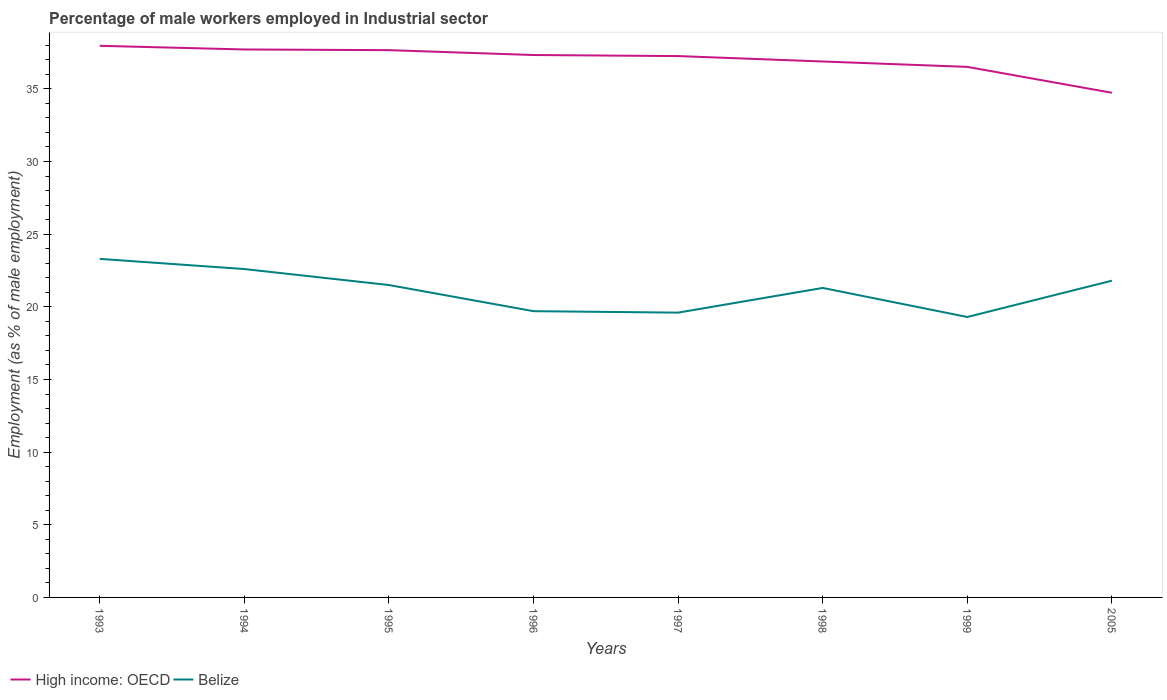Across all years, what is the maximum percentage of male workers employed in Industrial sector in High income: OECD?
Your answer should be compact. 34.73. What is the total percentage of male workers employed in Industrial sector in High income: OECD in the graph?
Offer a very short reply. 1.2. What is the difference between the highest and the second highest percentage of male workers employed in Industrial sector in Belize?
Keep it short and to the point. 4. What is the difference between the highest and the lowest percentage of male workers employed in Industrial sector in Belize?
Your response must be concise. 5. Are the values on the major ticks of Y-axis written in scientific E-notation?
Your answer should be very brief. No. Does the graph contain any zero values?
Make the answer very short. No. Where does the legend appear in the graph?
Your response must be concise. Bottom left. What is the title of the graph?
Give a very brief answer. Percentage of male workers employed in Industrial sector. Does "High income: nonOECD" appear as one of the legend labels in the graph?
Keep it short and to the point. No. What is the label or title of the Y-axis?
Your answer should be compact. Employment (as % of male employment). What is the Employment (as % of male employment) in High income: OECD in 1993?
Your response must be concise. 37.96. What is the Employment (as % of male employment) in Belize in 1993?
Offer a very short reply. 23.3. What is the Employment (as % of male employment) in High income: OECD in 1994?
Your answer should be very brief. 37.71. What is the Employment (as % of male employment) of Belize in 1994?
Keep it short and to the point. 22.6. What is the Employment (as % of male employment) of High income: OECD in 1995?
Your response must be concise. 37.66. What is the Employment (as % of male employment) of High income: OECD in 1996?
Your answer should be very brief. 37.33. What is the Employment (as % of male employment) of Belize in 1996?
Your response must be concise. 19.7. What is the Employment (as % of male employment) in High income: OECD in 1997?
Your answer should be very brief. 37.26. What is the Employment (as % of male employment) in Belize in 1997?
Give a very brief answer. 19.6. What is the Employment (as % of male employment) in High income: OECD in 1998?
Your answer should be very brief. 36.88. What is the Employment (as % of male employment) of Belize in 1998?
Offer a very short reply. 21.3. What is the Employment (as % of male employment) of High income: OECD in 1999?
Provide a succinct answer. 36.51. What is the Employment (as % of male employment) of Belize in 1999?
Keep it short and to the point. 19.3. What is the Employment (as % of male employment) in High income: OECD in 2005?
Keep it short and to the point. 34.73. What is the Employment (as % of male employment) in Belize in 2005?
Your answer should be compact. 21.8. Across all years, what is the maximum Employment (as % of male employment) of High income: OECD?
Provide a short and direct response. 37.96. Across all years, what is the maximum Employment (as % of male employment) of Belize?
Offer a terse response. 23.3. Across all years, what is the minimum Employment (as % of male employment) of High income: OECD?
Your response must be concise. 34.73. Across all years, what is the minimum Employment (as % of male employment) in Belize?
Your answer should be compact. 19.3. What is the total Employment (as % of male employment) in High income: OECD in the graph?
Your response must be concise. 296.05. What is the total Employment (as % of male employment) of Belize in the graph?
Offer a terse response. 169.1. What is the difference between the Employment (as % of male employment) in High income: OECD in 1993 and that in 1994?
Give a very brief answer. 0.25. What is the difference between the Employment (as % of male employment) of High income: OECD in 1993 and that in 1995?
Keep it short and to the point. 0.3. What is the difference between the Employment (as % of male employment) of High income: OECD in 1993 and that in 1996?
Provide a short and direct response. 0.63. What is the difference between the Employment (as % of male employment) in Belize in 1993 and that in 1996?
Offer a terse response. 3.6. What is the difference between the Employment (as % of male employment) of High income: OECD in 1993 and that in 1997?
Make the answer very short. 0.71. What is the difference between the Employment (as % of male employment) of High income: OECD in 1993 and that in 1998?
Offer a very short reply. 1.08. What is the difference between the Employment (as % of male employment) of High income: OECD in 1993 and that in 1999?
Provide a short and direct response. 1.45. What is the difference between the Employment (as % of male employment) in Belize in 1993 and that in 1999?
Keep it short and to the point. 4. What is the difference between the Employment (as % of male employment) of High income: OECD in 1993 and that in 2005?
Your answer should be very brief. 3.23. What is the difference between the Employment (as % of male employment) of High income: OECD in 1994 and that in 1995?
Give a very brief answer. 0.05. What is the difference between the Employment (as % of male employment) of High income: OECD in 1994 and that in 1996?
Keep it short and to the point. 0.38. What is the difference between the Employment (as % of male employment) of High income: OECD in 1994 and that in 1997?
Provide a succinct answer. 0.46. What is the difference between the Employment (as % of male employment) of High income: OECD in 1994 and that in 1998?
Keep it short and to the point. 0.83. What is the difference between the Employment (as % of male employment) in Belize in 1994 and that in 1998?
Give a very brief answer. 1.3. What is the difference between the Employment (as % of male employment) of High income: OECD in 1994 and that in 1999?
Ensure brevity in your answer.  1.2. What is the difference between the Employment (as % of male employment) in High income: OECD in 1994 and that in 2005?
Give a very brief answer. 2.98. What is the difference between the Employment (as % of male employment) of Belize in 1994 and that in 2005?
Your answer should be very brief. 0.8. What is the difference between the Employment (as % of male employment) in High income: OECD in 1995 and that in 1996?
Offer a terse response. 0.33. What is the difference between the Employment (as % of male employment) of Belize in 1995 and that in 1996?
Give a very brief answer. 1.8. What is the difference between the Employment (as % of male employment) in High income: OECD in 1995 and that in 1997?
Your answer should be very brief. 0.41. What is the difference between the Employment (as % of male employment) of Belize in 1995 and that in 1997?
Keep it short and to the point. 1.9. What is the difference between the Employment (as % of male employment) of High income: OECD in 1995 and that in 1998?
Your answer should be compact. 0.78. What is the difference between the Employment (as % of male employment) of High income: OECD in 1995 and that in 1999?
Offer a very short reply. 1.15. What is the difference between the Employment (as % of male employment) in Belize in 1995 and that in 1999?
Ensure brevity in your answer.  2.2. What is the difference between the Employment (as % of male employment) in High income: OECD in 1995 and that in 2005?
Give a very brief answer. 2.93. What is the difference between the Employment (as % of male employment) in High income: OECD in 1996 and that in 1997?
Ensure brevity in your answer.  0.07. What is the difference between the Employment (as % of male employment) in Belize in 1996 and that in 1997?
Give a very brief answer. 0.1. What is the difference between the Employment (as % of male employment) of High income: OECD in 1996 and that in 1998?
Provide a short and direct response. 0.45. What is the difference between the Employment (as % of male employment) of Belize in 1996 and that in 1998?
Provide a succinct answer. -1.6. What is the difference between the Employment (as % of male employment) of High income: OECD in 1996 and that in 1999?
Offer a terse response. 0.82. What is the difference between the Employment (as % of male employment) of Belize in 1996 and that in 1999?
Make the answer very short. 0.4. What is the difference between the Employment (as % of male employment) in High income: OECD in 1996 and that in 2005?
Offer a very short reply. 2.6. What is the difference between the Employment (as % of male employment) in Belize in 1996 and that in 2005?
Provide a short and direct response. -2.1. What is the difference between the Employment (as % of male employment) of High income: OECD in 1997 and that in 1998?
Ensure brevity in your answer.  0.37. What is the difference between the Employment (as % of male employment) of Belize in 1997 and that in 1998?
Your answer should be very brief. -1.7. What is the difference between the Employment (as % of male employment) of High income: OECD in 1997 and that in 1999?
Give a very brief answer. 0.74. What is the difference between the Employment (as % of male employment) of High income: OECD in 1997 and that in 2005?
Ensure brevity in your answer.  2.52. What is the difference between the Employment (as % of male employment) in High income: OECD in 1998 and that in 1999?
Make the answer very short. 0.37. What is the difference between the Employment (as % of male employment) of Belize in 1998 and that in 1999?
Keep it short and to the point. 2. What is the difference between the Employment (as % of male employment) in High income: OECD in 1998 and that in 2005?
Your answer should be compact. 2.15. What is the difference between the Employment (as % of male employment) of High income: OECD in 1999 and that in 2005?
Provide a short and direct response. 1.78. What is the difference between the Employment (as % of male employment) in High income: OECD in 1993 and the Employment (as % of male employment) in Belize in 1994?
Provide a short and direct response. 15.36. What is the difference between the Employment (as % of male employment) of High income: OECD in 1993 and the Employment (as % of male employment) of Belize in 1995?
Provide a succinct answer. 16.46. What is the difference between the Employment (as % of male employment) in High income: OECD in 1993 and the Employment (as % of male employment) in Belize in 1996?
Provide a succinct answer. 18.26. What is the difference between the Employment (as % of male employment) in High income: OECD in 1993 and the Employment (as % of male employment) in Belize in 1997?
Your response must be concise. 18.36. What is the difference between the Employment (as % of male employment) of High income: OECD in 1993 and the Employment (as % of male employment) of Belize in 1998?
Provide a short and direct response. 16.66. What is the difference between the Employment (as % of male employment) in High income: OECD in 1993 and the Employment (as % of male employment) in Belize in 1999?
Keep it short and to the point. 18.66. What is the difference between the Employment (as % of male employment) in High income: OECD in 1993 and the Employment (as % of male employment) in Belize in 2005?
Your response must be concise. 16.16. What is the difference between the Employment (as % of male employment) of High income: OECD in 1994 and the Employment (as % of male employment) of Belize in 1995?
Ensure brevity in your answer.  16.21. What is the difference between the Employment (as % of male employment) in High income: OECD in 1994 and the Employment (as % of male employment) in Belize in 1996?
Your answer should be compact. 18.01. What is the difference between the Employment (as % of male employment) in High income: OECD in 1994 and the Employment (as % of male employment) in Belize in 1997?
Make the answer very short. 18.11. What is the difference between the Employment (as % of male employment) of High income: OECD in 1994 and the Employment (as % of male employment) of Belize in 1998?
Your response must be concise. 16.41. What is the difference between the Employment (as % of male employment) of High income: OECD in 1994 and the Employment (as % of male employment) of Belize in 1999?
Offer a very short reply. 18.41. What is the difference between the Employment (as % of male employment) of High income: OECD in 1994 and the Employment (as % of male employment) of Belize in 2005?
Your response must be concise. 15.91. What is the difference between the Employment (as % of male employment) in High income: OECD in 1995 and the Employment (as % of male employment) in Belize in 1996?
Your answer should be compact. 17.96. What is the difference between the Employment (as % of male employment) of High income: OECD in 1995 and the Employment (as % of male employment) of Belize in 1997?
Provide a succinct answer. 18.06. What is the difference between the Employment (as % of male employment) in High income: OECD in 1995 and the Employment (as % of male employment) in Belize in 1998?
Keep it short and to the point. 16.36. What is the difference between the Employment (as % of male employment) of High income: OECD in 1995 and the Employment (as % of male employment) of Belize in 1999?
Your answer should be compact. 18.36. What is the difference between the Employment (as % of male employment) of High income: OECD in 1995 and the Employment (as % of male employment) of Belize in 2005?
Give a very brief answer. 15.86. What is the difference between the Employment (as % of male employment) in High income: OECD in 1996 and the Employment (as % of male employment) in Belize in 1997?
Offer a very short reply. 17.73. What is the difference between the Employment (as % of male employment) of High income: OECD in 1996 and the Employment (as % of male employment) of Belize in 1998?
Offer a terse response. 16.03. What is the difference between the Employment (as % of male employment) of High income: OECD in 1996 and the Employment (as % of male employment) of Belize in 1999?
Make the answer very short. 18.03. What is the difference between the Employment (as % of male employment) in High income: OECD in 1996 and the Employment (as % of male employment) in Belize in 2005?
Make the answer very short. 15.53. What is the difference between the Employment (as % of male employment) in High income: OECD in 1997 and the Employment (as % of male employment) in Belize in 1998?
Ensure brevity in your answer.  15.96. What is the difference between the Employment (as % of male employment) of High income: OECD in 1997 and the Employment (as % of male employment) of Belize in 1999?
Give a very brief answer. 17.96. What is the difference between the Employment (as % of male employment) of High income: OECD in 1997 and the Employment (as % of male employment) of Belize in 2005?
Your answer should be very brief. 15.46. What is the difference between the Employment (as % of male employment) of High income: OECD in 1998 and the Employment (as % of male employment) of Belize in 1999?
Make the answer very short. 17.58. What is the difference between the Employment (as % of male employment) in High income: OECD in 1998 and the Employment (as % of male employment) in Belize in 2005?
Provide a short and direct response. 15.08. What is the difference between the Employment (as % of male employment) in High income: OECD in 1999 and the Employment (as % of male employment) in Belize in 2005?
Ensure brevity in your answer.  14.71. What is the average Employment (as % of male employment) in High income: OECD per year?
Make the answer very short. 37.01. What is the average Employment (as % of male employment) in Belize per year?
Keep it short and to the point. 21.14. In the year 1993, what is the difference between the Employment (as % of male employment) in High income: OECD and Employment (as % of male employment) in Belize?
Provide a short and direct response. 14.66. In the year 1994, what is the difference between the Employment (as % of male employment) of High income: OECD and Employment (as % of male employment) of Belize?
Your answer should be very brief. 15.11. In the year 1995, what is the difference between the Employment (as % of male employment) in High income: OECD and Employment (as % of male employment) in Belize?
Your answer should be compact. 16.16. In the year 1996, what is the difference between the Employment (as % of male employment) in High income: OECD and Employment (as % of male employment) in Belize?
Your answer should be compact. 17.63. In the year 1997, what is the difference between the Employment (as % of male employment) of High income: OECD and Employment (as % of male employment) of Belize?
Keep it short and to the point. 17.66. In the year 1998, what is the difference between the Employment (as % of male employment) of High income: OECD and Employment (as % of male employment) of Belize?
Give a very brief answer. 15.58. In the year 1999, what is the difference between the Employment (as % of male employment) of High income: OECD and Employment (as % of male employment) of Belize?
Offer a terse response. 17.21. In the year 2005, what is the difference between the Employment (as % of male employment) of High income: OECD and Employment (as % of male employment) of Belize?
Your response must be concise. 12.93. What is the ratio of the Employment (as % of male employment) of Belize in 1993 to that in 1994?
Give a very brief answer. 1.03. What is the ratio of the Employment (as % of male employment) of High income: OECD in 1993 to that in 1995?
Make the answer very short. 1.01. What is the ratio of the Employment (as % of male employment) of Belize in 1993 to that in 1995?
Your answer should be compact. 1.08. What is the ratio of the Employment (as % of male employment) of High income: OECD in 1993 to that in 1996?
Your answer should be very brief. 1.02. What is the ratio of the Employment (as % of male employment) of Belize in 1993 to that in 1996?
Ensure brevity in your answer.  1.18. What is the ratio of the Employment (as % of male employment) in Belize in 1993 to that in 1997?
Provide a short and direct response. 1.19. What is the ratio of the Employment (as % of male employment) of High income: OECD in 1993 to that in 1998?
Ensure brevity in your answer.  1.03. What is the ratio of the Employment (as % of male employment) in Belize in 1993 to that in 1998?
Ensure brevity in your answer.  1.09. What is the ratio of the Employment (as % of male employment) in High income: OECD in 1993 to that in 1999?
Your answer should be very brief. 1.04. What is the ratio of the Employment (as % of male employment) of Belize in 1993 to that in 1999?
Offer a terse response. 1.21. What is the ratio of the Employment (as % of male employment) in High income: OECD in 1993 to that in 2005?
Ensure brevity in your answer.  1.09. What is the ratio of the Employment (as % of male employment) in Belize in 1993 to that in 2005?
Offer a terse response. 1.07. What is the ratio of the Employment (as % of male employment) in Belize in 1994 to that in 1995?
Offer a very short reply. 1.05. What is the ratio of the Employment (as % of male employment) of High income: OECD in 1994 to that in 1996?
Your answer should be compact. 1.01. What is the ratio of the Employment (as % of male employment) of Belize in 1994 to that in 1996?
Offer a very short reply. 1.15. What is the ratio of the Employment (as % of male employment) of High income: OECD in 1994 to that in 1997?
Ensure brevity in your answer.  1.01. What is the ratio of the Employment (as % of male employment) of Belize in 1994 to that in 1997?
Your answer should be very brief. 1.15. What is the ratio of the Employment (as % of male employment) of High income: OECD in 1994 to that in 1998?
Make the answer very short. 1.02. What is the ratio of the Employment (as % of male employment) in Belize in 1994 to that in 1998?
Offer a terse response. 1.06. What is the ratio of the Employment (as % of male employment) in High income: OECD in 1994 to that in 1999?
Your answer should be compact. 1.03. What is the ratio of the Employment (as % of male employment) in Belize in 1994 to that in 1999?
Your answer should be compact. 1.17. What is the ratio of the Employment (as % of male employment) in High income: OECD in 1994 to that in 2005?
Give a very brief answer. 1.09. What is the ratio of the Employment (as % of male employment) of Belize in 1994 to that in 2005?
Make the answer very short. 1.04. What is the ratio of the Employment (as % of male employment) of Belize in 1995 to that in 1996?
Your response must be concise. 1.09. What is the ratio of the Employment (as % of male employment) of High income: OECD in 1995 to that in 1997?
Ensure brevity in your answer.  1.01. What is the ratio of the Employment (as % of male employment) in Belize in 1995 to that in 1997?
Make the answer very short. 1.1. What is the ratio of the Employment (as % of male employment) in High income: OECD in 1995 to that in 1998?
Your answer should be compact. 1.02. What is the ratio of the Employment (as % of male employment) in Belize in 1995 to that in 1998?
Your answer should be very brief. 1.01. What is the ratio of the Employment (as % of male employment) of High income: OECD in 1995 to that in 1999?
Your answer should be compact. 1.03. What is the ratio of the Employment (as % of male employment) of Belize in 1995 to that in 1999?
Offer a terse response. 1.11. What is the ratio of the Employment (as % of male employment) in High income: OECD in 1995 to that in 2005?
Your answer should be very brief. 1.08. What is the ratio of the Employment (as % of male employment) of Belize in 1995 to that in 2005?
Keep it short and to the point. 0.99. What is the ratio of the Employment (as % of male employment) of High income: OECD in 1996 to that in 1997?
Provide a succinct answer. 1. What is the ratio of the Employment (as % of male employment) in High income: OECD in 1996 to that in 1998?
Your answer should be compact. 1.01. What is the ratio of the Employment (as % of male employment) in Belize in 1996 to that in 1998?
Give a very brief answer. 0.92. What is the ratio of the Employment (as % of male employment) in High income: OECD in 1996 to that in 1999?
Provide a succinct answer. 1.02. What is the ratio of the Employment (as % of male employment) of Belize in 1996 to that in 1999?
Give a very brief answer. 1.02. What is the ratio of the Employment (as % of male employment) in High income: OECD in 1996 to that in 2005?
Offer a terse response. 1.07. What is the ratio of the Employment (as % of male employment) in Belize in 1996 to that in 2005?
Offer a very short reply. 0.9. What is the ratio of the Employment (as % of male employment) in High income: OECD in 1997 to that in 1998?
Provide a succinct answer. 1.01. What is the ratio of the Employment (as % of male employment) in Belize in 1997 to that in 1998?
Your answer should be compact. 0.92. What is the ratio of the Employment (as % of male employment) in High income: OECD in 1997 to that in 1999?
Make the answer very short. 1.02. What is the ratio of the Employment (as % of male employment) in Belize in 1997 to that in 1999?
Offer a very short reply. 1.02. What is the ratio of the Employment (as % of male employment) of High income: OECD in 1997 to that in 2005?
Your answer should be compact. 1.07. What is the ratio of the Employment (as % of male employment) of Belize in 1997 to that in 2005?
Your response must be concise. 0.9. What is the ratio of the Employment (as % of male employment) of High income: OECD in 1998 to that in 1999?
Make the answer very short. 1.01. What is the ratio of the Employment (as % of male employment) in Belize in 1998 to that in 1999?
Your response must be concise. 1.1. What is the ratio of the Employment (as % of male employment) in High income: OECD in 1998 to that in 2005?
Provide a succinct answer. 1.06. What is the ratio of the Employment (as % of male employment) of Belize in 1998 to that in 2005?
Your answer should be compact. 0.98. What is the ratio of the Employment (as % of male employment) in High income: OECD in 1999 to that in 2005?
Your answer should be very brief. 1.05. What is the ratio of the Employment (as % of male employment) of Belize in 1999 to that in 2005?
Your response must be concise. 0.89. What is the difference between the highest and the second highest Employment (as % of male employment) in High income: OECD?
Your answer should be very brief. 0.25. What is the difference between the highest and the second highest Employment (as % of male employment) of Belize?
Your answer should be very brief. 0.7. What is the difference between the highest and the lowest Employment (as % of male employment) in High income: OECD?
Ensure brevity in your answer.  3.23. 